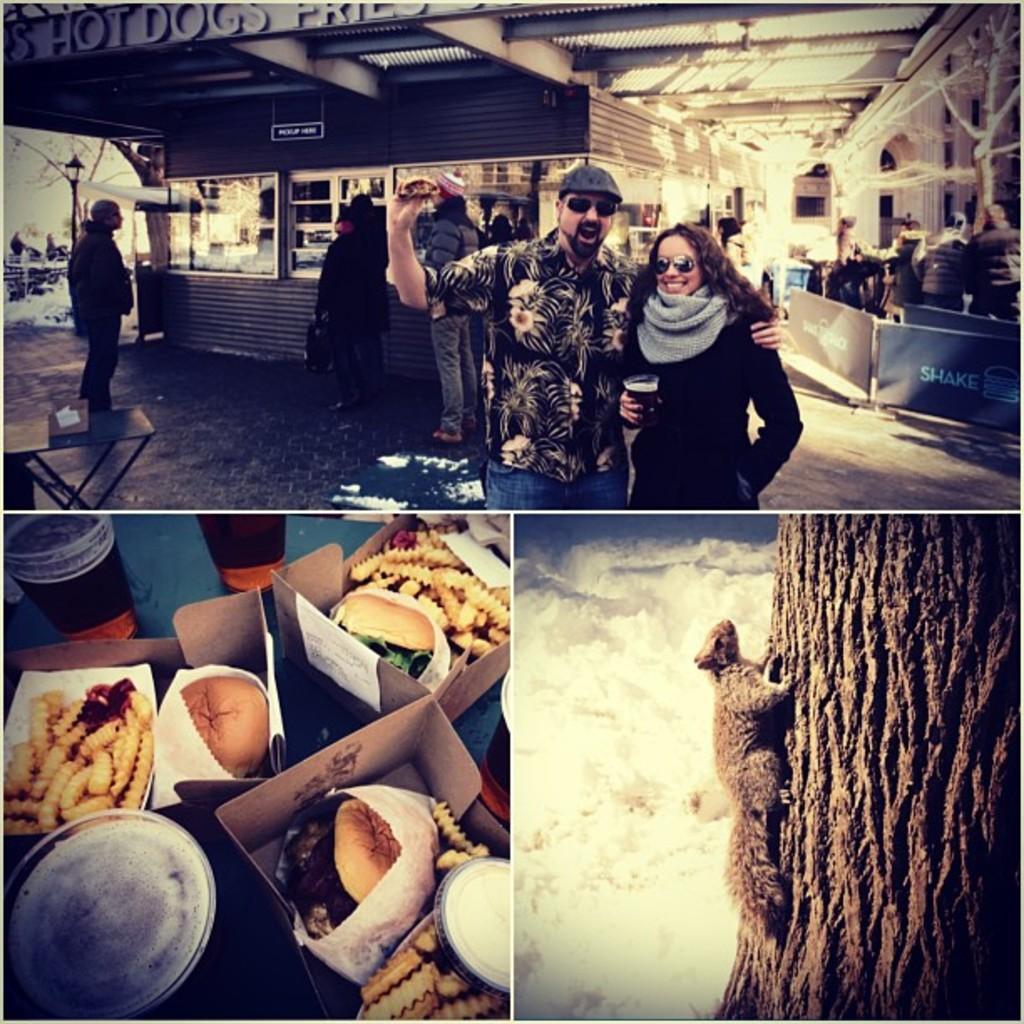Describe this image in one or two sentences. In this image I can see there is a collage of images, there is some food, two people standing and they are smiling. There is a squirrel climbing on the tree and there is water in the backdrop. 